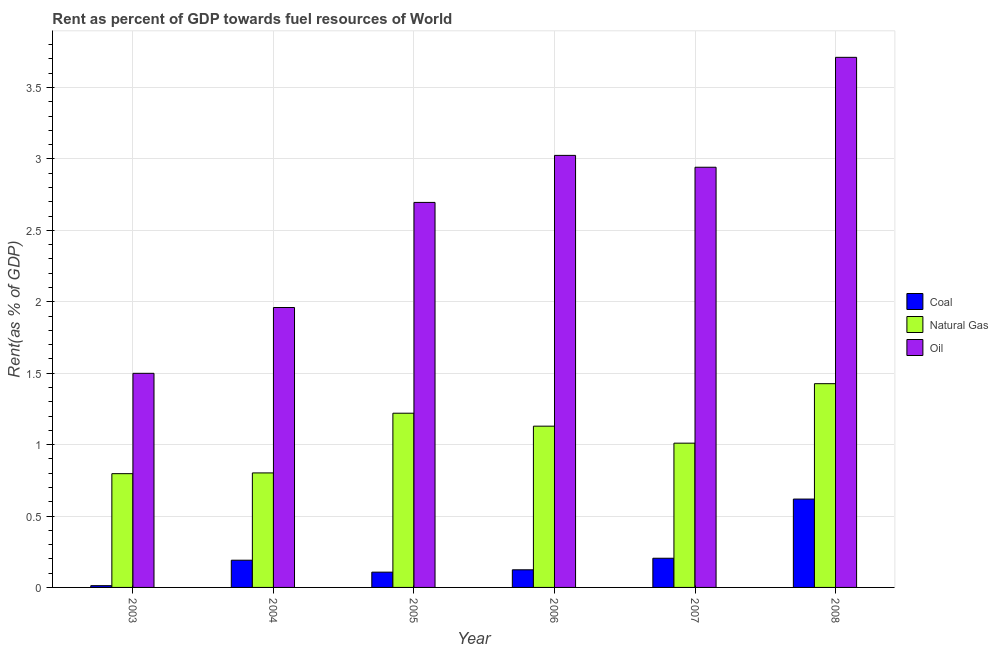How many different coloured bars are there?
Your response must be concise. 3. How many bars are there on the 3rd tick from the left?
Give a very brief answer. 3. How many bars are there on the 1st tick from the right?
Your response must be concise. 3. What is the rent towards oil in 2004?
Provide a succinct answer. 1.96. Across all years, what is the maximum rent towards oil?
Make the answer very short. 3.71. Across all years, what is the minimum rent towards natural gas?
Your answer should be very brief. 0.8. In which year was the rent towards coal maximum?
Make the answer very short. 2008. What is the total rent towards coal in the graph?
Make the answer very short. 1.26. What is the difference between the rent towards oil in 2004 and that in 2007?
Provide a succinct answer. -0.98. What is the difference between the rent towards coal in 2006 and the rent towards natural gas in 2003?
Offer a very short reply. 0.11. What is the average rent towards natural gas per year?
Your answer should be very brief. 1.06. In the year 2003, what is the difference between the rent towards oil and rent towards natural gas?
Your response must be concise. 0. What is the ratio of the rent towards coal in 2005 to that in 2007?
Provide a short and direct response. 0.52. Is the rent towards natural gas in 2006 less than that in 2008?
Provide a succinct answer. Yes. What is the difference between the highest and the second highest rent towards oil?
Offer a very short reply. 0.69. What is the difference between the highest and the lowest rent towards coal?
Ensure brevity in your answer.  0.61. What does the 2nd bar from the left in 2008 represents?
Offer a terse response. Natural Gas. What does the 2nd bar from the right in 2006 represents?
Your response must be concise. Natural Gas. How many years are there in the graph?
Your answer should be very brief. 6. Does the graph contain grids?
Make the answer very short. Yes. How many legend labels are there?
Your answer should be compact. 3. How are the legend labels stacked?
Your answer should be compact. Vertical. What is the title of the graph?
Offer a terse response. Rent as percent of GDP towards fuel resources of World. Does "Transport" appear as one of the legend labels in the graph?
Make the answer very short. No. What is the label or title of the Y-axis?
Your answer should be very brief. Rent(as % of GDP). What is the Rent(as % of GDP) in Coal in 2003?
Your answer should be compact. 0.01. What is the Rent(as % of GDP) in Natural Gas in 2003?
Your response must be concise. 0.8. What is the Rent(as % of GDP) of Oil in 2003?
Provide a short and direct response. 1.5. What is the Rent(as % of GDP) in Coal in 2004?
Offer a very short reply. 0.19. What is the Rent(as % of GDP) of Natural Gas in 2004?
Your answer should be compact. 0.8. What is the Rent(as % of GDP) in Oil in 2004?
Offer a very short reply. 1.96. What is the Rent(as % of GDP) in Coal in 2005?
Provide a succinct answer. 0.11. What is the Rent(as % of GDP) in Natural Gas in 2005?
Provide a succinct answer. 1.22. What is the Rent(as % of GDP) of Oil in 2005?
Offer a terse response. 2.7. What is the Rent(as % of GDP) in Coal in 2006?
Make the answer very short. 0.12. What is the Rent(as % of GDP) of Natural Gas in 2006?
Provide a succinct answer. 1.13. What is the Rent(as % of GDP) in Oil in 2006?
Your answer should be compact. 3.03. What is the Rent(as % of GDP) in Coal in 2007?
Provide a short and direct response. 0.2. What is the Rent(as % of GDP) in Natural Gas in 2007?
Your response must be concise. 1.01. What is the Rent(as % of GDP) of Oil in 2007?
Keep it short and to the point. 2.94. What is the Rent(as % of GDP) in Coal in 2008?
Give a very brief answer. 0.62. What is the Rent(as % of GDP) in Natural Gas in 2008?
Provide a short and direct response. 1.43. What is the Rent(as % of GDP) in Oil in 2008?
Your answer should be compact. 3.71. Across all years, what is the maximum Rent(as % of GDP) of Coal?
Provide a succinct answer. 0.62. Across all years, what is the maximum Rent(as % of GDP) in Natural Gas?
Your answer should be very brief. 1.43. Across all years, what is the maximum Rent(as % of GDP) of Oil?
Provide a short and direct response. 3.71. Across all years, what is the minimum Rent(as % of GDP) of Coal?
Make the answer very short. 0.01. Across all years, what is the minimum Rent(as % of GDP) of Natural Gas?
Your answer should be very brief. 0.8. Across all years, what is the minimum Rent(as % of GDP) in Oil?
Your response must be concise. 1.5. What is the total Rent(as % of GDP) of Coal in the graph?
Keep it short and to the point. 1.26. What is the total Rent(as % of GDP) in Natural Gas in the graph?
Keep it short and to the point. 6.38. What is the total Rent(as % of GDP) in Oil in the graph?
Offer a very short reply. 15.83. What is the difference between the Rent(as % of GDP) of Coal in 2003 and that in 2004?
Ensure brevity in your answer.  -0.18. What is the difference between the Rent(as % of GDP) of Natural Gas in 2003 and that in 2004?
Give a very brief answer. -0.01. What is the difference between the Rent(as % of GDP) in Oil in 2003 and that in 2004?
Give a very brief answer. -0.46. What is the difference between the Rent(as % of GDP) in Coal in 2003 and that in 2005?
Provide a succinct answer. -0.09. What is the difference between the Rent(as % of GDP) of Natural Gas in 2003 and that in 2005?
Offer a terse response. -0.42. What is the difference between the Rent(as % of GDP) of Oil in 2003 and that in 2005?
Offer a terse response. -1.2. What is the difference between the Rent(as % of GDP) in Coal in 2003 and that in 2006?
Your answer should be compact. -0.11. What is the difference between the Rent(as % of GDP) in Natural Gas in 2003 and that in 2006?
Offer a terse response. -0.33. What is the difference between the Rent(as % of GDP) in Oil in 2003 and that in 2006?
Offer a very short reply. -1.53. What is the difference between the Rent(as % of GDP) in Coal in 2003 and that in 2007?
Keep it short and to the point. -0.19. What is the difference between the Rent(as % of GDP) of Natural Gas in 2003 and that in 2007?
Ensure brevity in your answer.  -0.21. What is the difference between the Rent(as % of GDP) of Oil in 2003 and that in 2007?
Your answer should be very brief. -1.44. What is the difference between the Rent(as % of GDP) of Coal in 2003 and that in 2008?
Provide a succinct answer. -0.61. What is the difference between the Rent(as % of GDP) of Natural Gas in 2003 and that in 2008?
Keep it short and to the point. -0.63. What is the difference between the Rent(as % of GDP) in Oil in 2003 and that in 2008?
Give a very brief answer. -2.21. What is the difference between the Rent(as % of GDP) of Coal in 2004 and that in 2005?
Your response must be concise. 0.08. What is the difference between the Rent(as % of GDP) in Natural Gas in 2004 and that in 2005?
Keep it short and to the point. -0.42. What is the difference between the Rent(as % of GDP) of Oil in 2004 and that in 2005?
Make the answer very short. -0.74. What is the difference between the Rent(as % of GDP) in Coal in 2004 and that in 2006?
Give a very brief answer. 0.07. What is the difference between the Rent(as % of GDP) in Natural Gas in 2004 and that in 2006?
Make the answer very short. -0.33. What is the difference between the Rent(as % of GDP) in Oil in 2004 and that in 2006?
Provide a short and direct response. -1.07. What is the difference between the Rent(as % of GDP) of Coal in 2004 and that in 2007?
Keep it short and to the point. -0.01. What is the difference between the Rent(as % of GDP) of Natural Gas in 2004 and that in 2007?
Your answer should be compact. -0.21. What is the difference between the Rent(as % of GDP) of Oil in 2004 and that in 2007?
Provide a short and direct response. -0.98. What is the difference between the Rent(as % of GDP) of Coal in 2004 and that in 2008?
Give a very brief answer. -0.43. What is the difference between the Rent(as % of GDP) in Natural Gas in 2004 and that in 2008?
Give a very brief answer. -0.62. What is the difference between the Rent(as % of GDP) in Oil in 2004 and that in 2008?
Your answer should be compact. -1.75. What is the difference between the Rent(as % of GDP) of Coal in 2005 and that in 2006?
Ensure brevity in your answer.  -0.02. What is the difference between the Rent(as % of GDP) of Natural Gas in 2005 and that in 2006?
Provide a short and direct response. 0.09. What is the difference between the Rent(as % of GDP) in Oil in 2005 and that in 2006?
Your answer should be compact. -0.33. What is the difference between the Rent(as % of GDP) of Coal in 2005 and that in 2007?
Provide a succinct answer. -0.1. What is the difference between the Rent(as % of GDP) of Natural Gas in 2005 and that in 2007?
Make the answer very short. 0.21. What is the difference between the Rent(as % of GDP) of Oil in 2005 and that in 2007?
Your answer should be very brief. -0.25. What is the difference between the Rent(as % of GDP) of Coal in 2005 and that in 2008?
Keep it short and to the point. -0.51. What is the difference between the Rent(as % of GDP) of Natural Gas in 2005 and that in 2008?
Offer a terse response. -0.21. What is the difference between the Rent(as % of GDP) of Oil in 2005 and that in 2008?
Keep it short and to the point. -1.02. What is the difference between the Rent(as % of GDP) of Coal in 2006 and that in 2007?
Make the answer very short. -0.08. What is the difference between the Rent(as % of GDP) of Natural Gas in 2006 and that in 2007?
Give a very brief answer. 0.12. What is the difference between the Rent(as % of GDP) of Oil in 2006 and that in 2007?
Offer a very short reply. 0.08. What is the difference between the Rent(as % of GDP) in Coal in 2006 and that in 2008?
Provide a short and direct response. -0.5. What is the difference between the Rent(as % of GDP) of Natural Gas in 2006 and that in 2008?
Keep it short and to the point. -0.3. What is the difference between the Rent(as % of GDP) of Oil in 2006 and that in 2008?
Give a very brief answer. -0.69. What is the difference between the Rent(as % of GDP) of Coal in 2007 and that in 2008?
Provide a short and direct response. -0.41. What is the difference between the Rent(as % of GDP) of Natural Gas in 2007 and that in 2008?
Offer a terse response. -0.42. What is the difference between the Rent(as % of GDP) of Oil in 2007 and that in 2008?
Keep it short and to the point. -0.77. What is the difference between the Rent(as % of GDP) of Coal in 2003 and the Rent(as % of GDP) of Natural Gas in 2004?
Give a very brief answer. -0.79. What is the difference between the Rent(as % of GDP) of Coal in 2003 and the Rent(as % of GDP) of Oil in 2004?
Your answer should be compact. -1.95. What is the difference between the Rent(as % of GDP) of Natural Gas in 2003 and the Rent(as % of GDP) of Oil in 2004?
Your answer should be compact. -1.16. What is the difference between the Rent(as % of GDP) of Coal in 2003 and the Rent(as % of GDP) of Natural Gas in 2005?
Provide a succinct answer. -1.21. What is the difference between the Rent(as % of GDP) of Coal in 2003 and the Rent(as % of GDP) of Oil in 2005?
Ensure brevity in your answer.  -2.68. What is the difference between the Rent(as % of GDP) of Natural Gas in 2003 and the Rent(as % of GDP) of Oil in 2005?
Keep it short and to the point. -1.9. What is the difference between the Rent(as % of GDP) of Coal in 2003 and the Rent(as % of GDP) of Natural Gas in 2006?
Your answer should be very brief. -1.12. What is the difference between the Rent(as % of GDP) in Coal in 2003 and the Rent(as % of GDP) in Oil in 2006?
Offer a very short reply. -3.01. What is the difference between the Rent(as % of GDP) in Natural Gas in 2003 and the Rent(as % of GDP) in Oil in 2006?
Offer a terse response. -2.23. What is the difference between the Rent(as % of GDP) in Coal in 2003 and the Rent(as % of GDP) in Natural Gas in 2007?
Make the answer very short. -1. What is the difference between the Rent(as % of GDP) of Coal in 2003 and the Rent(as % of GDP) of Oil in 2007?
Ensure brevity in your answer.  -2.93. What is the difference between the Rent(as % of GDP) in Natural Gas in 2003 and the Rent(as % of GDP) in Oil in 2007?
Provide a short and direct response. -2.15. What is the difference between the Rent(as % of GDP) in Coal in 2003 and the Rent(as % of GDP) in Natural Gas in 2008?
Make the answer very short. -1.41. What is the difference between the Rent(as % of GDP) in Coal in 2003 and the Rent(as % of GDP) in Oil in 2008?
Provide a short and direct response. -3.7. What is the difference between the Rent(as % of GDP) of Natural Gas in 2003 and the Rent(as % of GDP) of Oil in 2008?
Make the answer very short. -2.92. What is the difference between the Rent(as % of GDP) of Coal in 2004 and the Rent(as % of GDP) of Natural Gas in 2005?
Keep it short and to the point. -1.03. What is the difference between the Rent(as % of GDP) of Coal in 2004 and the Rent(as % of GDP) of Oil in 2005?
Your answer should be very brief. -2.51. What is the difference between the Rent(as % of GDP) in Natural Gas in 2004 and the Rent(as % of GDP) in Oil in 2005?
Ensure brevity in your answer.  -1.89. What is the difference between the Rent(as % of GDP) of Coal in 2004 and the Rent(as % of GDP) of Natural Gas in 2006?
Your answer should be very brief. -0.94. What is the difference between the Rent(as % of GDP) of Coal in 2004 and the Rent(as % of GDP) of Oil in 2006?
Provide a succinct answer. -2.83. What is the difference between the Rent(as % of GDP) in Natural Gas in 2004 and the Rent(as % of GDP) in Oil in 2006?
Make the answer very short. -2.22. What is the difference between the Rent(as % of GDP) in Coal in 2004 and the Rent(as % of GDP) in Natural Gas in 2007?
Give a very brief answer. -0.82. What is the difference between the Rent(as % of GDP) in Coal in 2004 and the Rent(as % of GDP) in Oil in 2007?
Make the answer very short. -2.75. What is the difference between the Rent(as % of GDP) in Natural Gas in 2004 and the Rent(as % of GDP) in Oil in 2007?
Your response must be concise. -2.14. What is the difference between the Rent(as % of GDP) in Coal in 2004 and the Rent(as % of GDP) in Natural Gas in 2008?
Your answer should be very brief. -1.24. What is the difference between the Rent(as % of GDP) of Coal in 2004 and the Rent(as % of GDP) of Oil in 2008?
Offer a very short reply. -3.52. What is the difference between the Rent(as % of GDP) of Natural Gas in 2004 and the Rent(as % of GDP) of Oil in 2008?
Provide a short and direct response. -2.91. What is the difference between the Rent(as % of GDP) in Coal in 2005 and the Rent(as % of GDP) in Natural Gas in 2006?
Provide a short and direct response. -1.02. What is the difference between the Rent(as % of GDP) in Coal in 2005 and the Rent(as % of GDP) in Oil in 2006?
Offer a very short reply. -2.92. What is the difference between the Rent(as % of GDP) of Natural Gas in 2005 and the Rent(as % of GDP) of Oil in 2006?
Offer a terse response. -1.81. What is the difference between the Rent(as % of GDP) of Coal in 2005 and the Rent(as % of GDP) of Natural Gas in 2007?
Make the answer very short. -0.9. What is the difference between the Rent(as % of GDP) in Coal in 2005 and the Rent(as % of GDP) in Oil in 2007?
Your answer should be very brief. -2.83. What is the difference between the Rent(as % of GDP) of Natural Gas in 2005 and the Rent(as % of GDP) of Oil in 2007?
Give a very brief answer. -1.72. What is the difference between the Rent(as % of GDP) in Coal in 2005 and the Rent(as % of GDP) in Natural Gas in 2008?
Offer a terse response. -1.32. What is the difference between the Rent(as % of GDP) of Coal in 2005 and the Rent(as % of GDP) of Oil in 2008?
Ensure brevity in your answer.  -3.6. What is the difference between the Rent(as % of GDP) of Natural Gas in 2005 and the Rent(as % of GDP) of Oil in 2008?
Your answer should be compact. -2.49. What is the difference between the Rent(as % of GDP) in Coal in 2006 and the Rent(as % of GDP) in Natural Gas in 2007?
Offer a terse response. -0.89. What is the difference between the Rent(as % of GDP) in Coal in 2006 and the Rent(as % of GDP) in Oil in 2007?
Offer a very short reply. -2.82. What is the difference between the Rent(as % of GDP) of Natural Gas in 2006 and the Rent(as % of GDP) of Oil in 2007?
Keep it short and to the point. -1.81. What is the difference between the Rent(as % of GDP) of Coal in 2006 and the Rent(as % of GDP) of Natural Gas in 2008?
Your response must be concise. -1.3. What is the difference between the Rent(as % of GDP) of Coal in 2006 and the Rent(as % of GDP) of Oil in 2008?
Give a very brief answer. -3.59. What is the difference between the Rent(as % of GDP) of Natural Gas in 2006 and the Rent(as % of GDP) of Oil in 2008?
Keep it short and to the point. -2.58. What is the difference between the Rent(as % of GDP) in Coal in 2007 and the Rent(as % of GDP) in Natural Gas in 2008?
Ensure brevity in your answer.  -1.22. What is the difference between the Rent(as % of GDP) in Coal in 2007 and the Rent(as % of GDP) in Oil in 2008?
Ensure brevity in your answer.  -3.51. What is the difference between the Rent(as % of GDP) of Natural Gas in 2007 and the Rent(as % of GDP) of Oil in 2008?
Offer a very short reply. -2.7. What is the average Rent(as % of GDP) of Coal per year?
Offer a terse response. 0.21. What is the average Rent(as % of GDP) in Natural Gas per year?
Make the answer very short. 1.06. What is the average Rent(as % of GDP) of Oil per year?
Ensure brevity in your answer.  2.64. In the year 2003, what is the difference between the Rent(as % of GDP) of Coal and Rent(as % of GDP) of Natural Gas?
Offer a terse response. -0.78. In the year 2003, what is the difference between the Rent(as % of GDP) in Coal and Rent(as % of GDP) in Oil?
Make the answer very short. -1.49. In the year 2003, what is the difference between the Rent(as % of GDP) in Natural Gas and Rent(as % of GDP) in Oil?
Your response must be concise. -0.7. In the year 2004, what is the difference between the Rent(as % of GDP) in Coal and Rent(as % of GDP) in Natural Gas?
Provide a short and direct response. -0.61. In the year 2004, what is the difference between the Rent(as % of GDP) in Coal and Rent(as % of GDP) in Oil?
Your answer should be compact. -1.77. In the year 2004, what is the difference between the Rent(as % of GDP) of Natural Gas and Rent(as % of GDP) of Oil?
Provide a short and direct response. -1.16. In the year 2005, what is the difference between the Rent(as % of GDP) of Coal and Rent(as % of GDP) of Natural Gas?
Your answer should be very brief. -1.11. In the year 2005, what is the difference between the Rent(as % of GDP) of Coal and Rent(as % of GDP) of Oil?
Make the answer very short. -2.59. In the year 2005, what is the difference between the Rent(as % of GDP) in Natural Gas and Rent(as % of GDP) in Oil?
Your answer should be very brief. -1.48. In the year 2006, what is the difference between the Rent(as % of GDP) of Coal and Rent(as % of GDP) of Natural Gas?
Give a very brief answer. -1.01. In the year 2006, what is the difference between the Rent(as % of GDP) of Coal and Rent(as % of GDP) of Oil?
Your response must be concise. -2.9. In the year 2006, what is the difference between the Rent(as % of GDP) of Natural Gas and Rent(as % of GDP) of Oil?
Ensure brevity in your answer.  -1.9. In the year 2007, what is the difference between the Rent(as % of GDP) of Coal and Rent(as % of GDP) of Natural Gas?
Your answer should be compact. -0.81. In the year 2007, what is the difference between the Rent(as % of GDP) in Coal and Rent(as % of GDP) in Oil?
Offer a terse response. -2.74. In the year 2007, what is the difference between the Rent(as % of GDP) of Natural Gas and Rent(as % of GDP) of Oil?
Provide a succinct answer. -1.93. In the year 2008, what is the difference between the Rent(as % of GDP) in Coal and Rent(as % of GDP) in Natural Gas?
Your answer should be compact. -0.81. In the year 2008, what is the difference between the Rent(as % of GDP) in Coal and Rent(as % of GDP) in Oil?
Provide a succinct answer. -3.09. In the year 2008, what is the difference between the Rent(as % of GDP) in Natural Gas and Rent(as % of GDP) in Oil?
Offer a very short reply. -2.29. What is the ratio of the Rent(as % of GDP) of Coal in 2003 to that in 2004?
Your answer should be compact. 0.06. What is the ratio of the Rent(as % of GDP) in Oil in 2003 to that in 2004?
Offer a very short reply. 0.76. What is the ratio of the Rent(as % of GDP) in Coal in 2003 to that in 2005?
Your answer should be very brief. 0.12. What is the ratio of the Rent(as % of GDP) in Natural Gas in 2003 to that in 2005?
Your answer should be compact. 0.65. What is the ratio of the Rent(as % of GDP) of Oil in 2003 to that in 2005?
Give a very brief answer. 0.56. What is the ratio of the Rent(as % of GDP) of Coal in 2003 to that in 2006?
Offer a very short reply. 0.1. What is the ratio of the Rent(as % of GDP) in Natural Gas in 2003 to that in 2006?
Your response must be concise. 0.71. What is the ratio of the Rent(as % of GDP) of Oil in 2003 to that in 2006?
Provide a short and direct response. 0.5. What is the ratio of the Rent(as % of GDP) in Coal in 2003 to that in 2007?
Your answer should be compact. 0.06. What is the ratio of the Rent(as % of GDP) of Natural Gas in 2003 to that in 2007?
Offer a terse response. 0.79. What is the ratio of the Rent(as % of GDP) in Oil in 2003 to that in 2007?
Ensure brevity in your answer.  0.51. What is the ratio of the Rent(as % of GDP) of Natural Gas in 2003 to that in 2008?
Your response must be concise. 0.56. What is the ratio of the Rent(as % of GDP) of Oil in 2003 to that in 2008?
Offer a terse response. 0.4. What is the ratio of the Rent(as % of GDP) in Coal in 2004 to that in 2005?
Your answer should be very brief. 1.78. What is the ratio of the Rent(as % of GDP) of Natural Gas in 2004 to that in 2005?
Your answer should be compact. 0.66. What is the ratio of the Rent(as % of GDP) in Oil in 2004 to that in 2005?
Your answer should be very brief. 0.73. What is the ratio of the Rent(as % of GDP) of Coal in 2004 to that in 2006?
Your answer should be very brief. 1.54. What is the ratio of the Rent(as % of GDP) in Natural Gas in 2004 to that in 2006?
Your response must be concise. 0.71. What is the ratio of the Rent(as % of GDP) of Oil in 2004 to that in 2006?
Make the answer very short. 0.65. What is the ratio of the Rent(as % of GDP) in Coal in 2004 to that in 2007?
Make the answer very short. 0.93. What is the ratio of the Rent(as % of GDP) of Natural Gas in 2004 to that in 2007?
Offer a terse response. 0.79. What is the ratio of the Rent(as % of GDP) in Oil in 2004 to that in 2007?
Provide a short and direct response. 0.67. What is the ratio of the Rent(as % of GDP) of Coal in 2004 to that in 2008?
Your answer should be compact. 0.31. What is the ratio of the Rent(as % of GDP) of Natural Gas in 2004 to that in 2008?
Provide a succinct answer. 0.56. What is the ratio of the Rent(as % of GDP) in Oil in 2004 to that in 2008?
Ensure brevity in your answer.  0.53. What is the ratio of the Rent(as % of GDP) in Coal in 2005 to that in 2006?
Offer a terse response. 0.87. What is the ratio of the Rent(as % of GDP) of Natural Gas in 2005 to that in 2006?
Offer a terse response. 1.08. What is the ratio of the Rent(as % of GDP) of Oil in 2005 to that in 2006?
Provide a short and direct response. 0.89. What is the ratio of the Rent(as % of GDP) in Coal in 2005 to that in 2007?
Your response must be concise. 0.52. What is the ratio of the Rent(as % of GDP) of Natural Gas in 2005 to that in 2007?
Ensure brevity in your answer.  1.21. What is the ratio of the Rent(as % of GDP) of Oil in 2005 to that in 2007?
Give a very brief answer. 0.92. What is the ratio of the Rent(as % of GDP) in Coal in 2005 to that in 2008?
Provide a succinct answer. 0.17. What is the ratio of the Rent(as % of GDP) in Natural Gas in 2005 to that in 2008?
Give a very brief answer. 0.86. What is the ratio of the Rent(as % of GDP) of Oil in 2005 to that in 2008?
Make the answer very short. 0.73. What is the ratio of the Rent(as % of GDP) in Coal in 2006 to that in 2007?
Offer a terse response. 0.6. What is the ratio of the Rent(as % of GDP) in Natural Gas in 2006 to that in 2007?
Make the answer very short. 1.12. What is the ratio of the Rent(as % of GDP) in Oil in 2006 to that in 2007?
Provide a short and direct response. 1.03. What is the ratio of the Rent(as % of GDP) in Coal in 2006 to that in 2008?
Offer a terse response. 0.2. What is the ratio of the Rent(as % of GDP) in Natural Gas in 2006 to that in 2008?
Your answer should be compact. 0.79. What is the ratio of the Rent(as % of GDP) in Oil in 2006 to that in 2008?
Your response must be concise. 0.81. What is the ratio of the Rent(as % of GDP) in Coal in 2007 to that in 2008?
Provide a succinct answer. 0.33. What is the ratio of the Rent(as % of GDP) of Natural Gas in 2007 to that in 2008?
Offer a very short reply. 0.71. What is the ratio of the Rent(as % of GDP) of Oil in 2007 to that in 2008?
Your response must be concise. 0.79. What is the difference between the highest and the second highest Rent(as % of GDP) in Coal?
Offer a terse response. 0.41. What is the difference between the highest and the second highest Rent(as % of GDP) in Natural Gas?
Offer a terse response. 0.21. What is the difference between the highest and the second highest Rent(as % of GDP) in Oil?
Your answer should be very brief. 0.69. What is the difference between the highest and the lowest Rent(as % of GDP) in Coal?
Make the answer very short. 0.61. What is the difference between the highest and the lowest Rent(as % of GDP) in Natural Gas?
Ensure brevity in your answer.  0.63. What is the difference between the highest and the lowest Rent(as % of GDP) of Oil?
Provide a succinct answer. 2.21. 